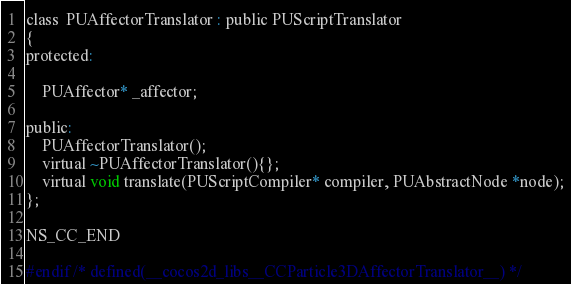<code> <loc_0><loc_0><loc_500><loc_500><_C_>class  PUAffectorTranslator : public PUScriptTranslator
{
protected:

    PUAffector* _affector;
    
public:
    PUAffectorTranslator();
    virtual ~PUAffectorTranslator(){};
    virtual void translate(PUScriptCompiler* compiler, PUAbstractNode *node);
};

NS_CC_END

#endif /* defined(__cocos2d_libs__CCParticle3DAffectorTranslator__) */
</code> 